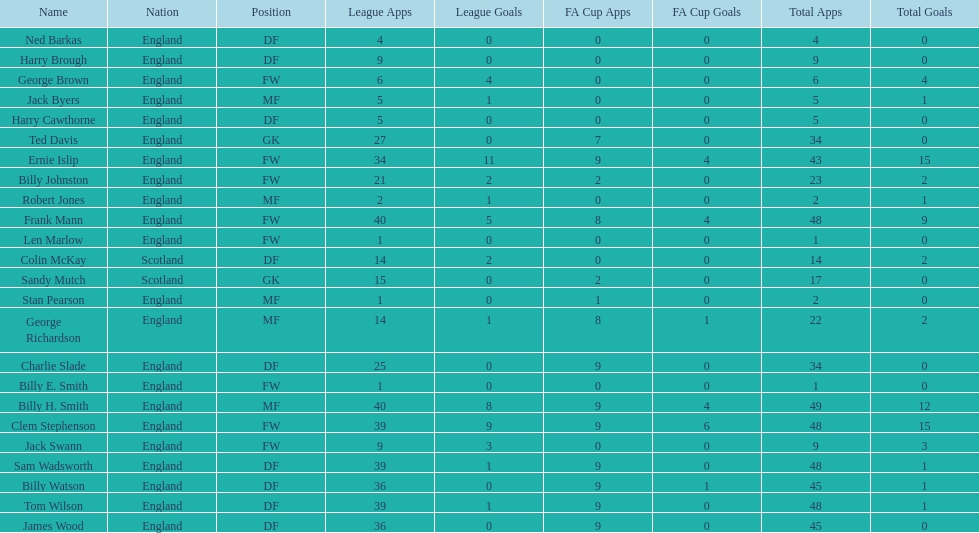The least number of total appearances 1. 